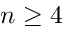Convert formula to latex. <formula><loc_0><loc_0><loc_500><loc_500>n \geq 4</formula> 